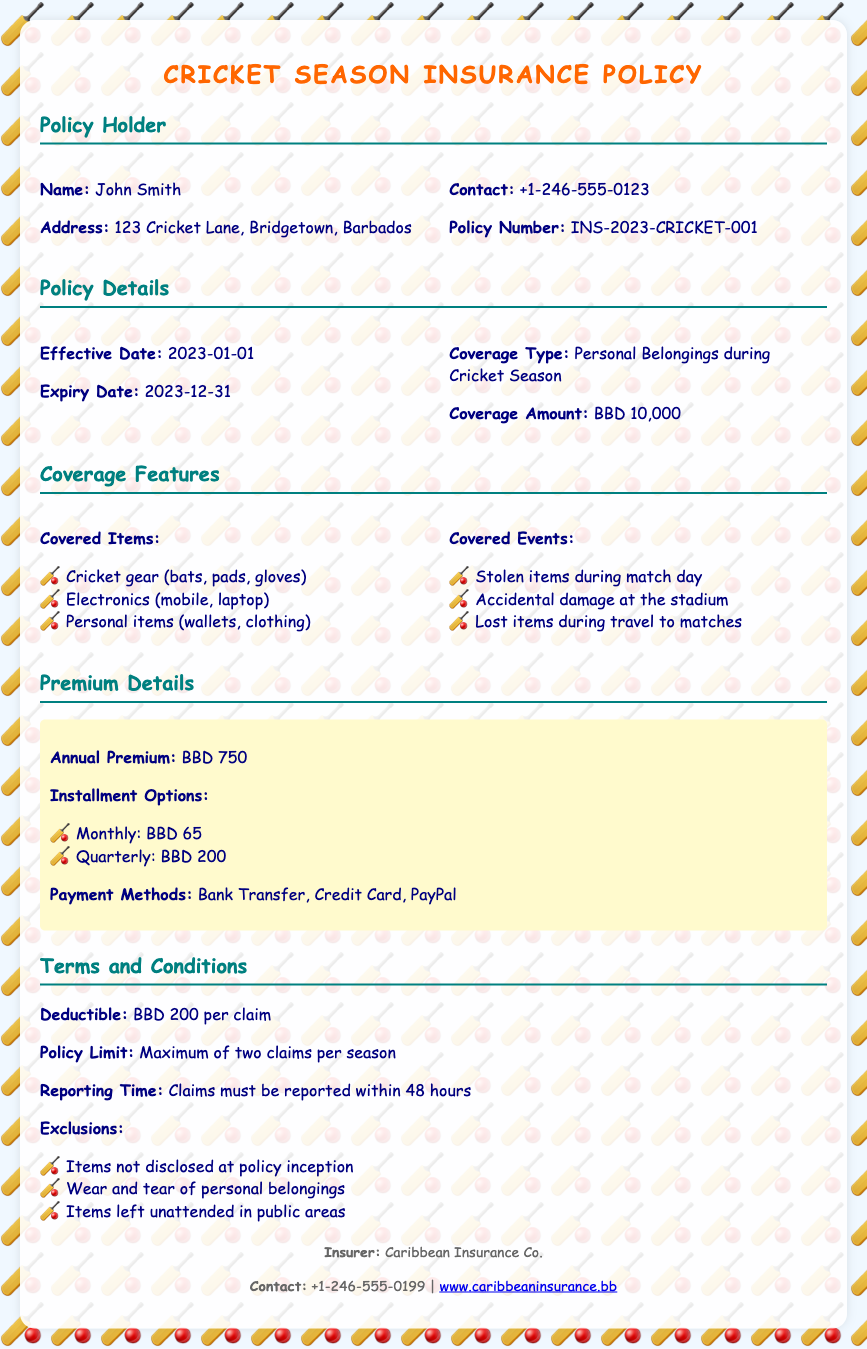What is the policy holder's name? The name of the policy holder is specified in the policy details section of the document.
Answer: John Smith What is the coverage amount? The coverage amount is clearly stated under the policy details section.
Answer: BBD 10,000 What is the annual premium? The annual premium is mentioned in the premium details section of the document.
Answer: BBD 750 How many claims are allowed per season? The policy limit for claims is discussed under the terms and conditions section.
Answer: Two claims What items are covered? The covered items are listed under the coverage features section of the document.
Answer: Cricket gear (bats, pads, gloves), Electronics (mobile, laptop), Personal items (wallets, clothing) What is the deductible per claim? The deductible amount is found in the terms and conditions part of the document.
Answer: BBD 200 What are the installment options? The document specifies the installment options under the premium details section.
Answer: Monthly: BBD 65, Quarterly: BBD 200 What must be done within 48 hours? The requirement regarding the reporting time for claims is mentioned in the terms and conditions.
Answer: Claims must be reported What are the payment methods available? The payment methods are described in the premium details section of the document.
Answer: Bank Transfer, Credit Card, PayPal Who is the insurer? The name of the insurer is provided in the footer of the document.
Answer: Caribbean Insurance Co 